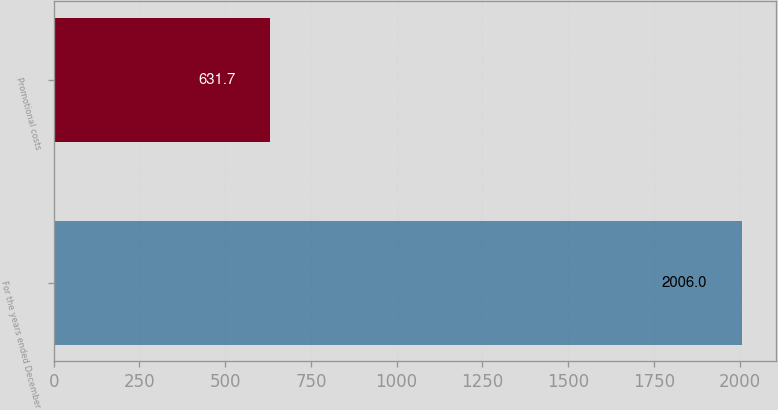Convert chart to OTSL. <chart><loc_0><loc_0><loc_500><loc_500><bar_chart><fcel>For the years ended December<fcel>Promotional costs<nl><fcel>2006<fcel>631.7<nl></chart> 